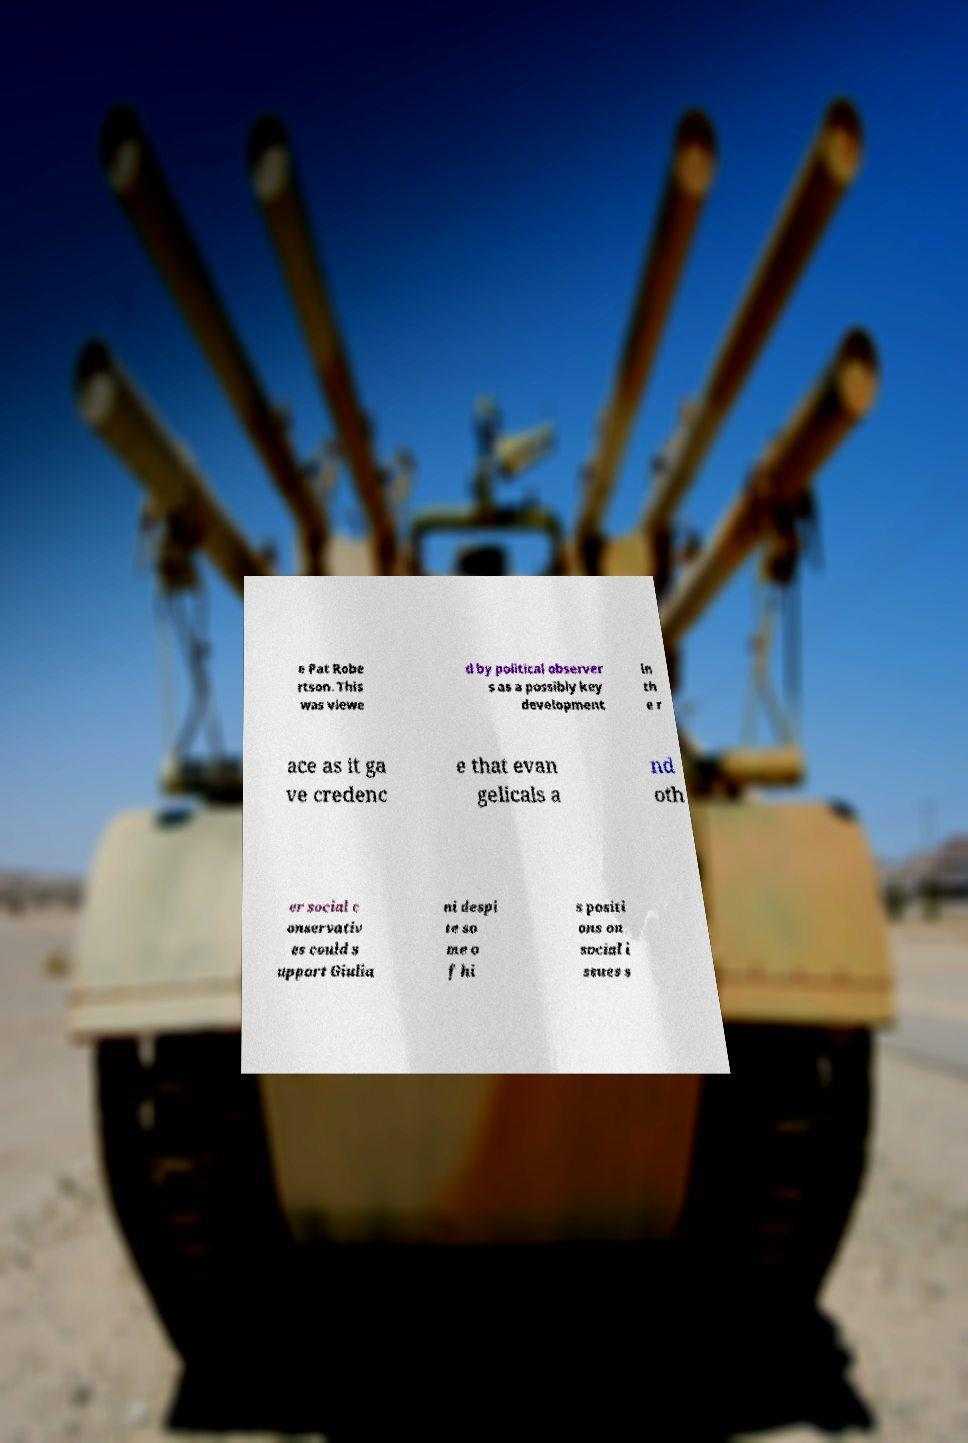Could you extract and type out the text from this image? e Pat Robe rtson. This was viewe d by political observer s as a possibly key development in th e r ace as it ga ve credenc e that evan gelicals a nd oth er social c onservativ es could s upport Giulia ni despi te so me o f hi s positi ons on social i ssues s 